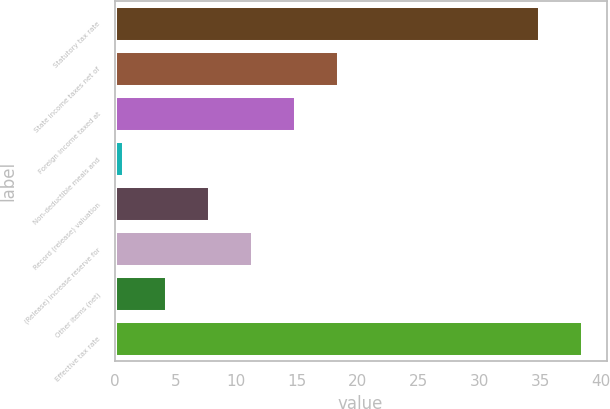<chart> <loc_0><loc_0><loc_500><loc_500><bar_chart><fcel>Statutory tax rate<fcel>State income taxes net of<fcel>Foreign income taxed at<fcel>Non-deductible meals and<fcel>Record (release) valuation<fcel>(Release) increase reserve for<fcel>Other items (net)<fcel>Effective tax rate<nl><fcel>35<fcel>18.4<fcel>14.88<fcel>0.8<fcel>7.84<fcel>11.36<fcel>4.32<fcel>38.52<nl></chart> 